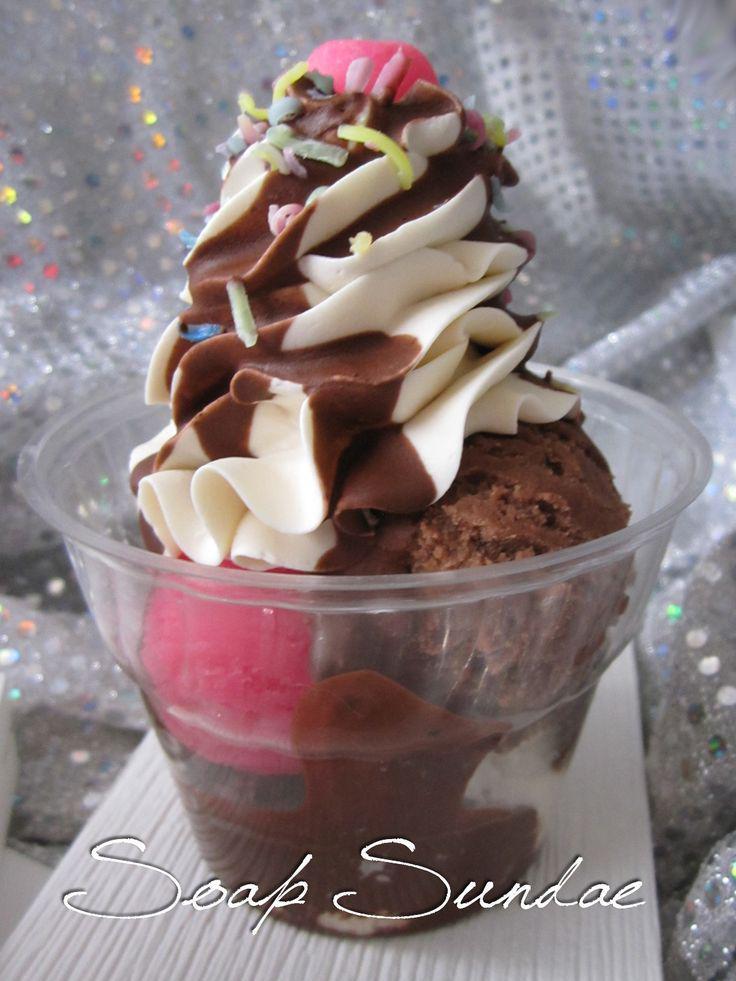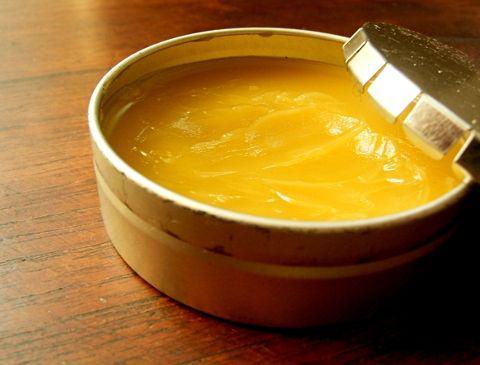The first image is the image on the left, the second image is the image on the right. Considering the images on both sides, is "An image includes an item of silverware and a clear unlidded glass jar containing a creamy pale yellow substance." valid? Answer yes or no. No. The first image is the image on the left, the second image is the image on the right. Examine the images to the left and right. Is the description "There is a glass jar filled with a light yellow substance in each of the images." accurate? Answer yes or no. No. 